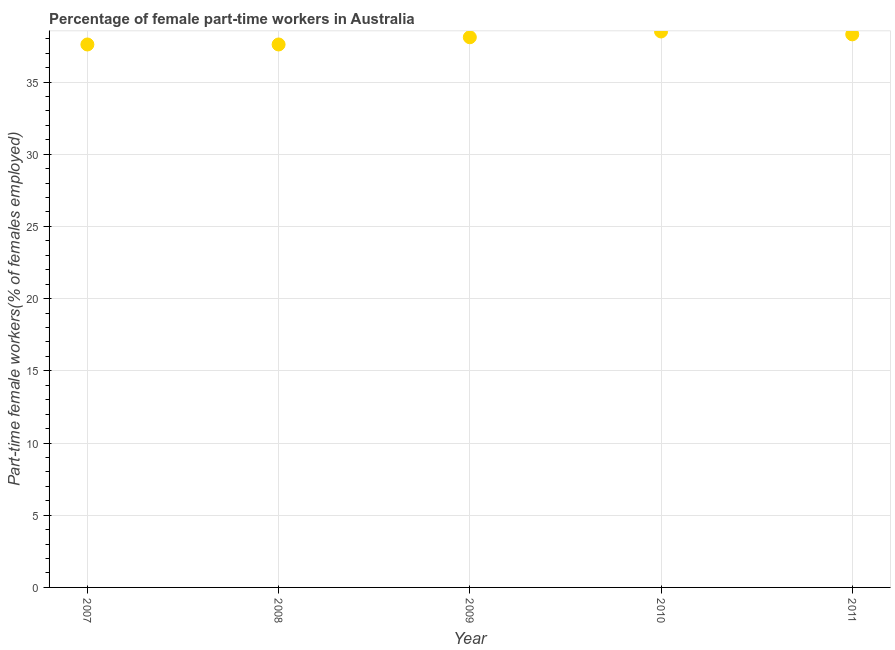What is the percentage of part-time female workers in 2007?
Provide a short and direct response. 37.6. Across all years, what is the maximum percentage of part-time female workers?
Provide a short and direct response. 38.5. Across all years, what is the minimum percentage of part-time female workers?
Ensure brevity in your answer.  37.6. What is the sum of the percentage of part-time female workers?
Provide a succinct answer. 190.1. What is the difference between the percentage of part-time female workers in 2007 and 2010?
Give a very brief answer. -0.9. What is the average percentage of part-time female workers per year?
Your answer should be very brief. 38.02. What is the median percentage of part-time female workers?
Give a very brief answer. 38.1. Do a majority of the years between 2009 and 2007 (inclusive) have percentage of part-time female workers greater than 16 %?
Your answer should be compact. No. What is the ratio of the percentage of part-time female workers in 2007 to that in 2010?
Keep it short and to the point. 0.98. Is the difference between the percentage of part-time female workers in 2007 and 2008 greater than the difference between any two years?
Offer a terse response. No. What is the difference between the highest and the second highest percentage of part-time female workers?
Give a very brief answer. 0.2. Is the sum of the percentage of part-time female workers in 2009 and 2011 greater than the maximum percentage of part-time female workers across all years?
Offer a terse response. Yes. What is the difference between the highest and the lowest percentage of part-time female workers?
Ensure brevity in your answer.  0.9. In how many years, is the percentage of part-time female workers greater than the average percentage of part-time female workers taken over all years?
Provide a short and direct response. 3. Does the percentage of part-time female workers monotonically increase over the years?
Make the answer very short. No. How many dotlines are there?
Offer a terse response. 1. How many years are there in the graph?
Provide a succinct answer. 5. Does the graph contain any zero values?
Offer a terse response. No. Does the graph contain grids?
Your response must be concise. Yes. What is the title of the graph?
Make the answer very short. Percentage of female part-time workers in Australia. What is the label or title of the Y-axis?
Give a very brief answer. Part-time female workers(% of females employed). What is the Part-time female workers(% of females employed) in 2007?
Your response must be concise. 37.6. What is the Part-time female workers(% of females employed) in 2008?
Offer a terse response. 37.6. What is the Part-time female workers(% of females employed) in 2009?
Your answer should be compact. 38.1. What is the Part-time female workers(% of females employed) in 2010?
Offer a very short reply. 38.5. What is the Part-time female workers(% of females employed) in 2011?
Make the answer very short. 38.3. What is the difference between the Part-time female workers(% of females employed) in 2007 and 2010?
Make the answer very short. -0.9. What is the difference between the Part-time female workers(% of females employed) in 2009 and 2010?
Your answer should be very brief. -0.4. What is the difference between the Part-time female workers(% of females employed) in 2010 and 2011?
Offer a very short reply. 0.2. What is the ratio of the Part-time female workers(% of females employed) in 2007 to that in 2008?
Ensure brevity in your answer.  1. What is the ratio of the Part-time female workers(% of females employed) in 2007 to that in 2010?
Offer a very short reply. 0.98. What is the ratio of the Part-time female workers(% of females employed) in 2007 to that in 2011?
Your answer should be compact. 0.98. What is the ratio of the Part-time female workers(% of females employed) in 2008 to that in 2009?
Ensure brevity in your answer.  0.99. What is the ratio of the Part-time female workers(% of females employed) in 2008 to that in 2010?
Offer a very short reply. 0.98. What is the ratio of the Part-time female workers(% of females employed) in 2008 to that in 2011?
Make the answer very short. 0.98. What is the ratio of the Part-time female workers(% of females employed) in 2010 to that in 2011?
Provide a succinct answer. 1. 